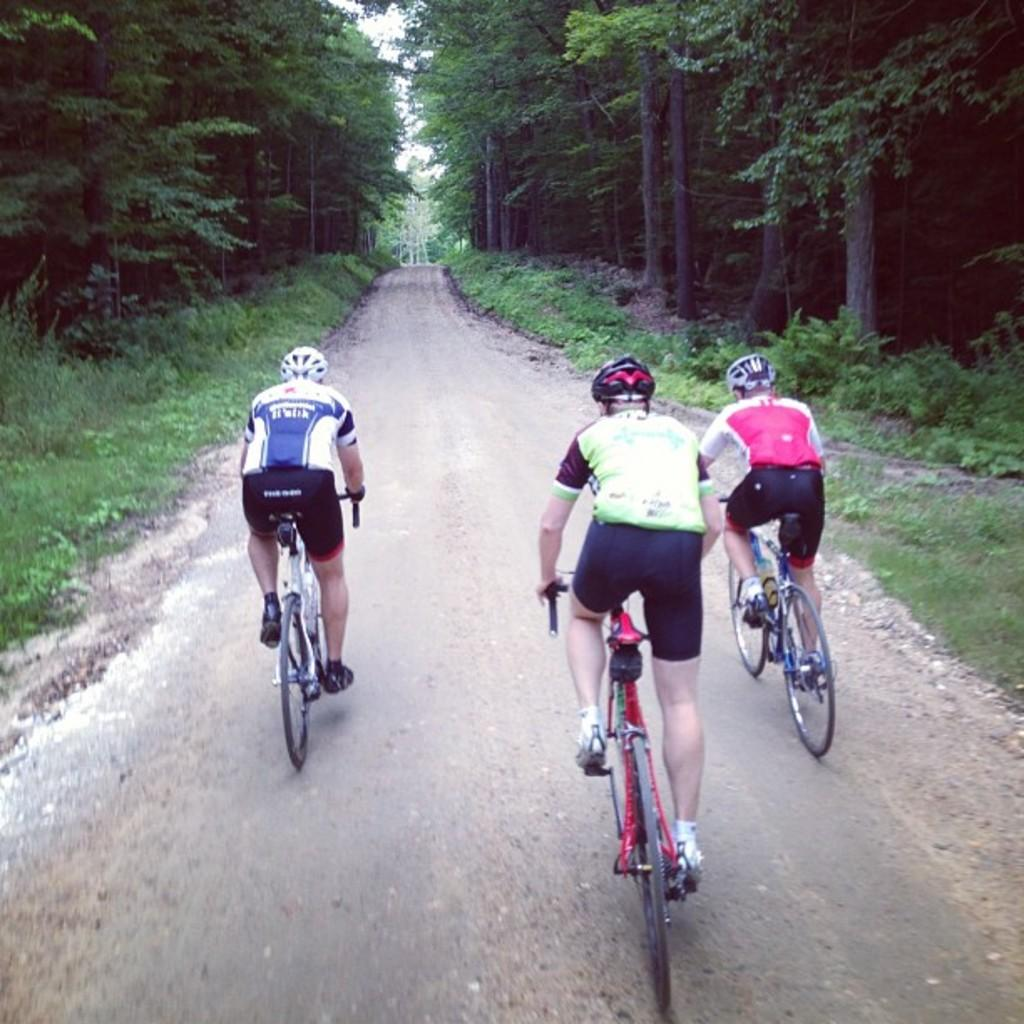How many people are in the image? There are three men in the image. What are the men doing in the image? The men are riding a bicycle. What can be seen in the background of the image? There are trees in the background of the image. What type of wire can be seen connecting the bicycle to the cars in the image? There are no cars or wires present in the image; it only features three men riding a bicycle with trees in the background. 